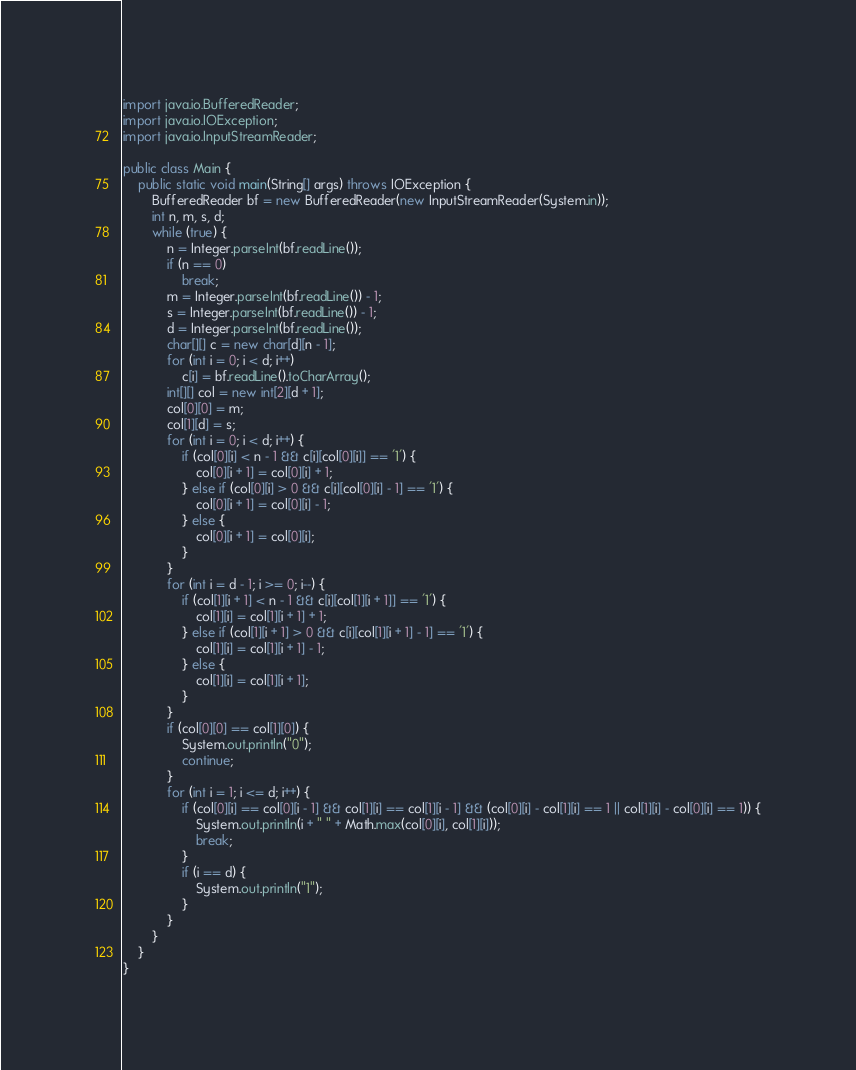<code> <loc_0><loc_0><loc_500><loc_500><_Java_>import java.io.BufferedReader;
import java.io.IOException;
import java.io.InputStreamReader;

public class Main {
	public static void main(String[] args) throws IOException {
		BufferedReader bf = new BufferedReader(new InputStreamReader(System.in));
		int n, m, s, d;
		while (true) {
			n = Integer.parseInt(bf.readLine());
			if (n == 0)
				break;
			m = Integer.parseInt(bf.readLine()) - 1;
			s = Integer.parseInt(bf.readLine()) - 1;
			d = Integer.parseInt(bf.readLine());
			char[][] c = new char[d][n - 1];
			for (int i = 0; i < d; i++)
				c[i] = bf.readLine().toCharArray();
			int[][] col = new int[2][d + 1];
			col[0][0] = m;
			col[1][d] = s;
			for (int i = 0; i < d; i++) {
				if (col[0][i] < n - 1 && c[i][col[0][i]] == '1') {
					col[0][i + 1] = col[0][i] + 1;
				} else if (col[0][i] > 0 && c[i][col[0][i] - 1] == '1') {
					col[0][i + 1] = col[0][i] - 1;
				} else {
					col[0][i + 1] = col[0][i];
				}
			}
			for (int i = d - 1; i >= 0; i--) {
				if (col[1][i + 1] < n - 1 && c[i][col[1][i + 1]] == '1') {
					col[1][i] = col[1][i + 1] + 1;
				} else if (col[1][i + 1] > 0 && c[i][col[1][i + 1] - 1] == '1') {
					col[1][i] = col[1][i + 1] - 1;
				} else {
					col[1][i] = col[1][i + 1];
				}
			}
			if (col[0][0] == col[1][0]) {
				System.out.println("0");
				continue;
			}
			for (int i = 1; i <= d; i++) {
				if (col[0][i] == col[0][i - 1] && col[1][i] == col[1][i - 1] && (col[0][i] - col[1][i] == 1 || col[1][i] - col[0][i] == 1)) {
					System.out.println(i + " " + Math.max(col[0][i], col[1][i]));
					break;
				}
				if (i == d) {
					System.out.println("1");
				}
			}
		}
	}
}</code> 